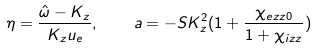Convert formula to latex. <formula><loc_0><loc_0><loc_500><loc_500>\eta = \frac { \hat { \omega } - K _ { z } } { K _ { z } u _ { e } } , \quad a = - S K _ { z } ^ { 2 } ( 1 + \frac { \chi _ { e z z 0 } } { 1 + \chi _ { i z z } } )</formula> 